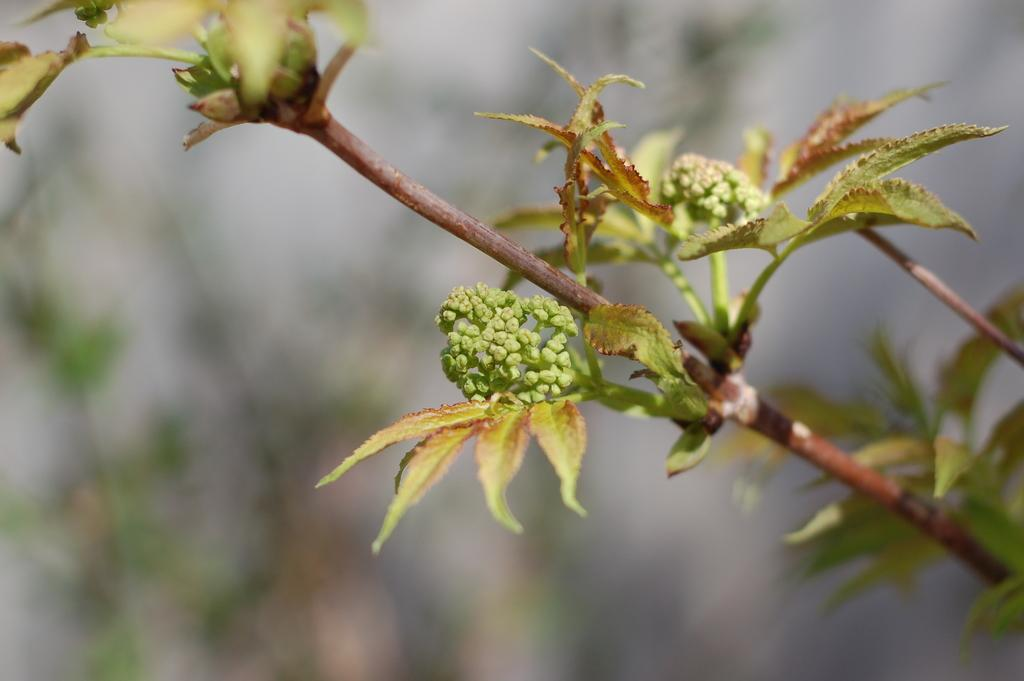What type of living organisms can be seen in the image? Plants can be seen in the image. Can you describe the background of the image? The background of the image is blurry. What impulse can be seen affecting the plants in the image? There is no impulse affecting the plants in the image; they are stationary. What type of plate is visible in the image? There is no plate present in the image. 